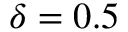Convert formula to latex. <formula><loc_0><loc_0><loc_500><loc_500>\delta = 0 . 5</formula> 